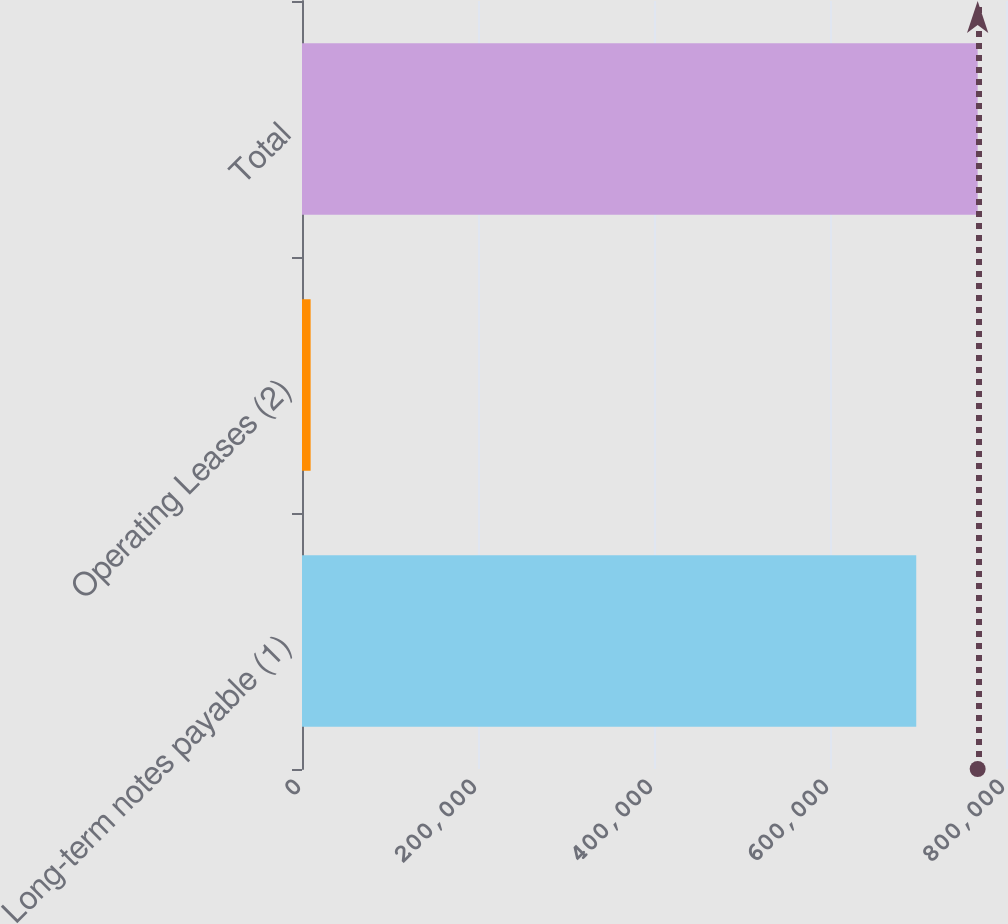Convert chart to OTSL. <chart><loc_0><loc_0><loc_500><loc_500><bar_chart><fcel>Long-term notes payable (1)<fcel>Operating Leases (2)<fcel>Total<nl><fcel>698000<fcel>9807<fcel>767800<nl></chart> 